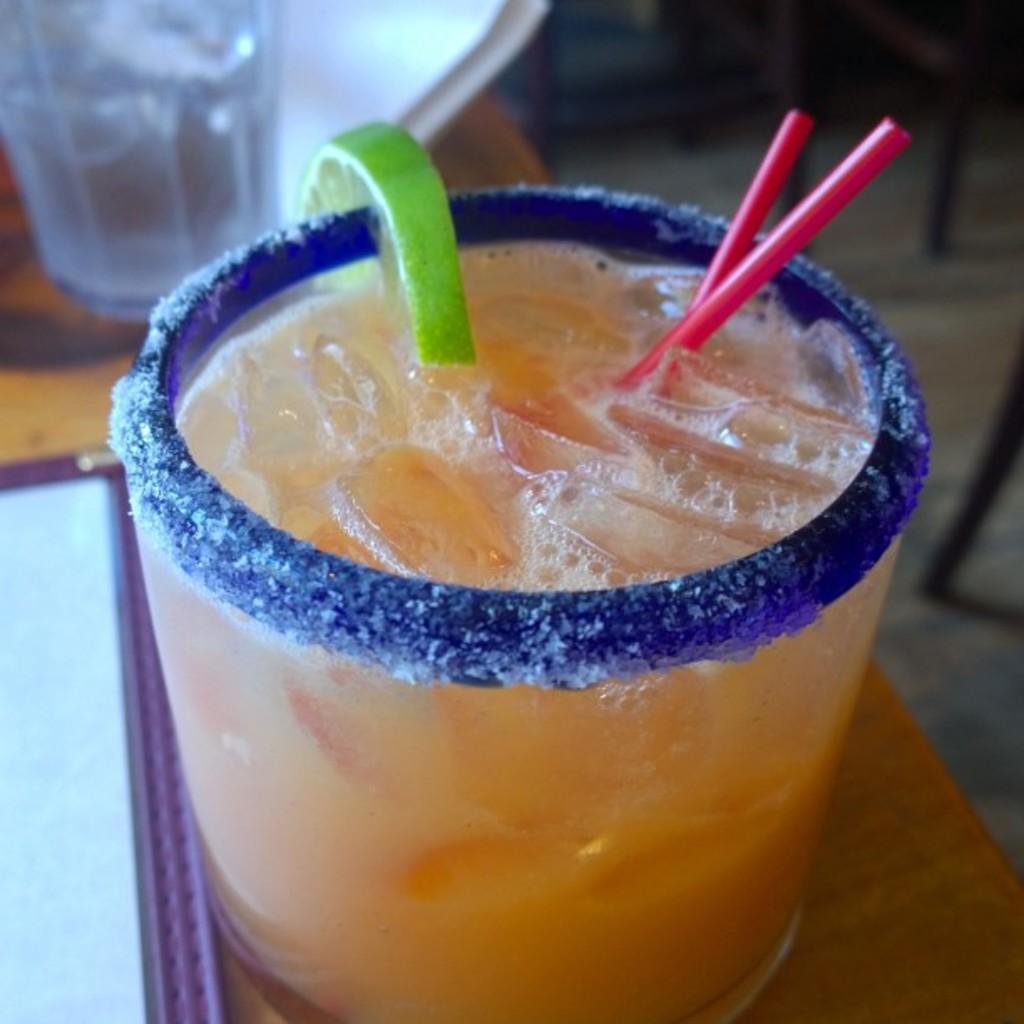Can you describe this image briefly? There is a glass with juice, ice cubes, lemon piece and straws. And the glass is on a table. 